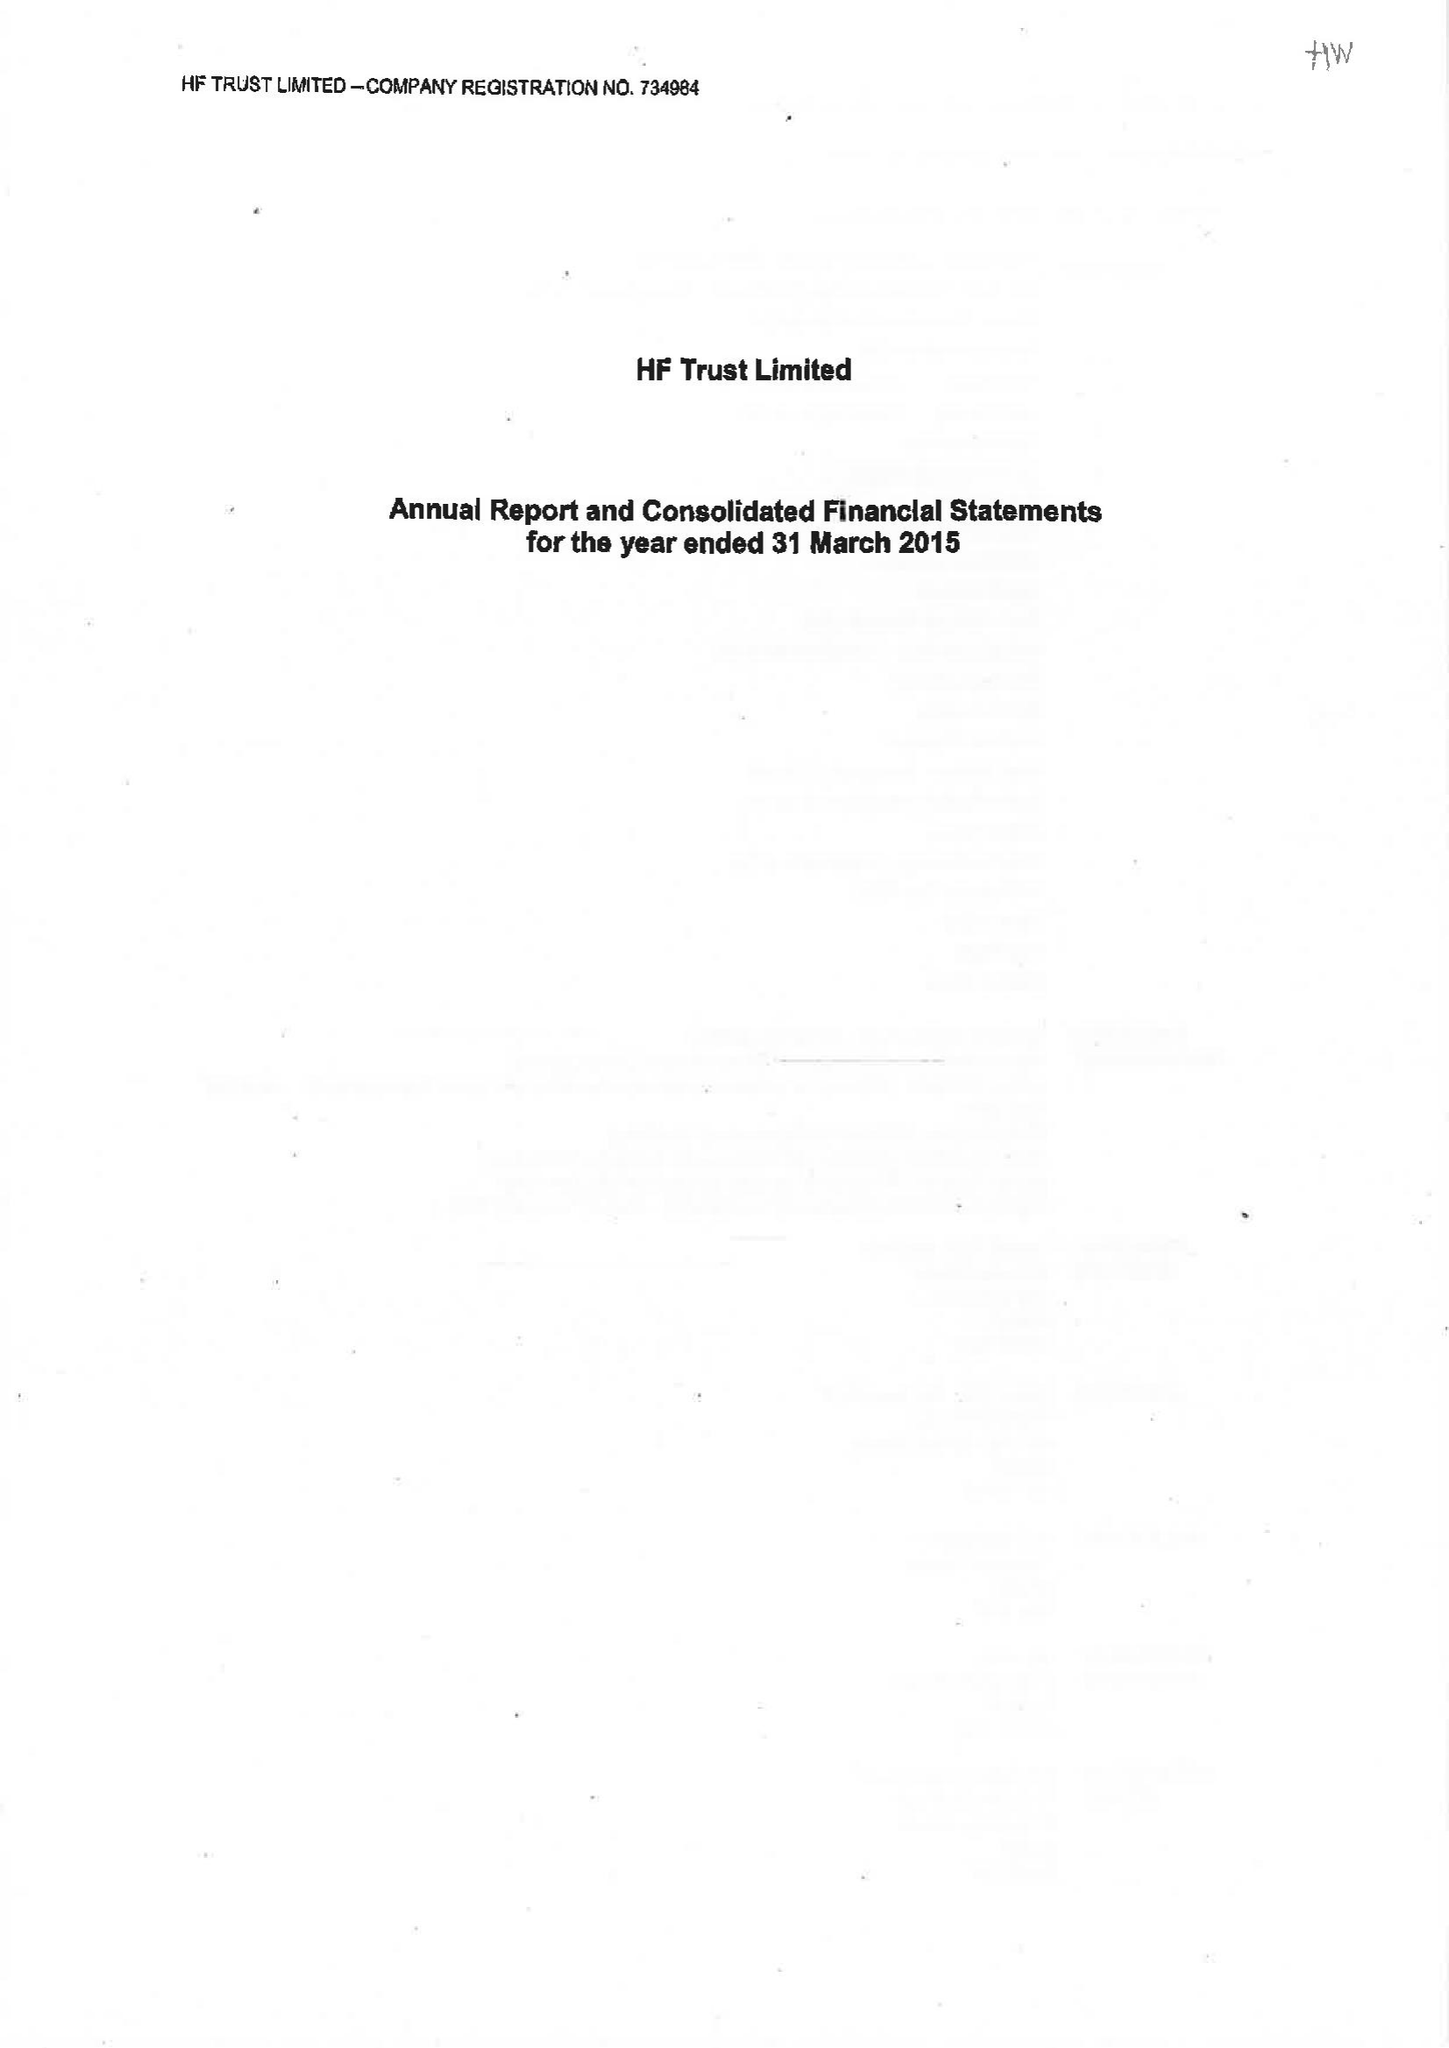What is the value for the charity_number?
Answer the question using a single word or phrase. 313069 